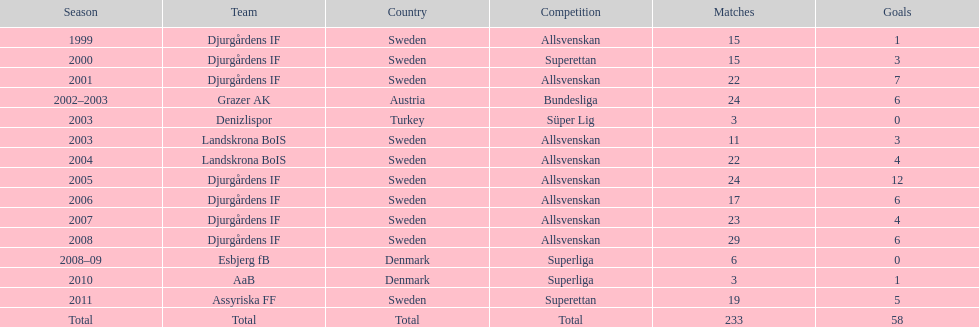What is the total number of matches? 233. 